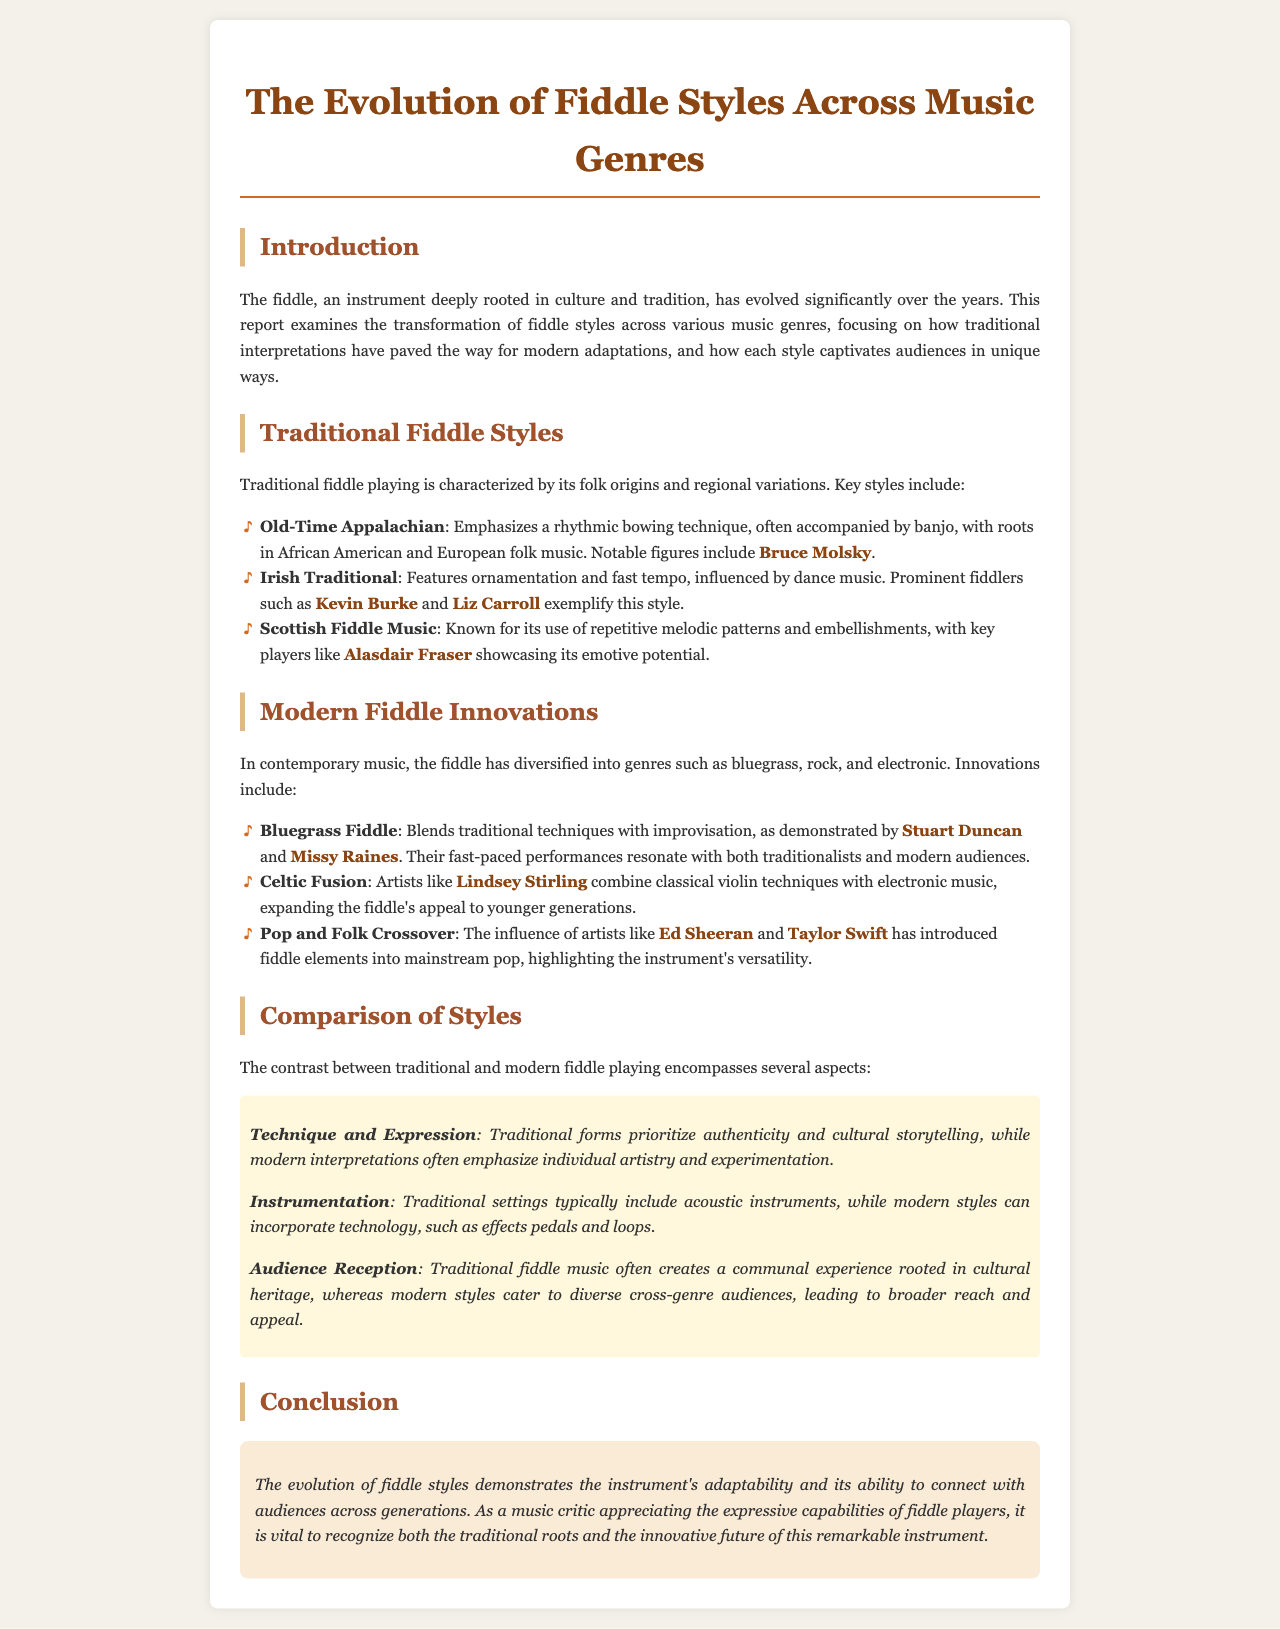What is the main focus of the report? The report examines the transformation of fiddle styles across various music genres.
Answer: Transformation of fiddle styles across various music genres Who is a notable figure in Old-Time Appalachian fiddle playing? Bruce Molsky is mentioned as a key figure in Old-Time Appalachian fiddle playing.
Answer: Bruce Molsky What genre emphasizes individual artistry and experimentation? Modern interpretations of fiddle playing are noted for emphasizing individual artistry and experimentation.
Answer: Modern interpretations Which instrument is typically included in traditional fiddle settings? Acoustic instruments are commonly included in traditional fiddle settings.
Answer: Acoustic instruments Who are two artists involved in Bluegrass Fiddle? Stuart Duncan and Missy Raines are highlighted as artists in Bluegrass Fiddle.
Answer: Stuart Duncan and Missy Raines 